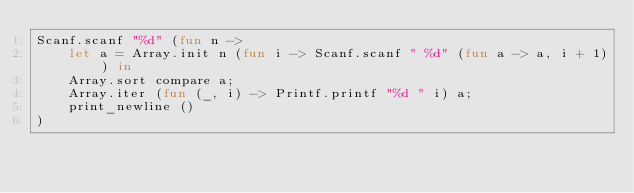<code> <loc_0><loc_0><loc_500><loc_500><_OCaml_>Scanf.scanf "%d" (fun n ->
    let a = Array.init n (fun i -> Scanf.scanf " %d" (fun a -> a, i + 1)) in
    Array.sort compare a;
    Array.iter (fun (_, i) -> Printf.printf "%d " i) a;
    print_newline ()
)</code> 